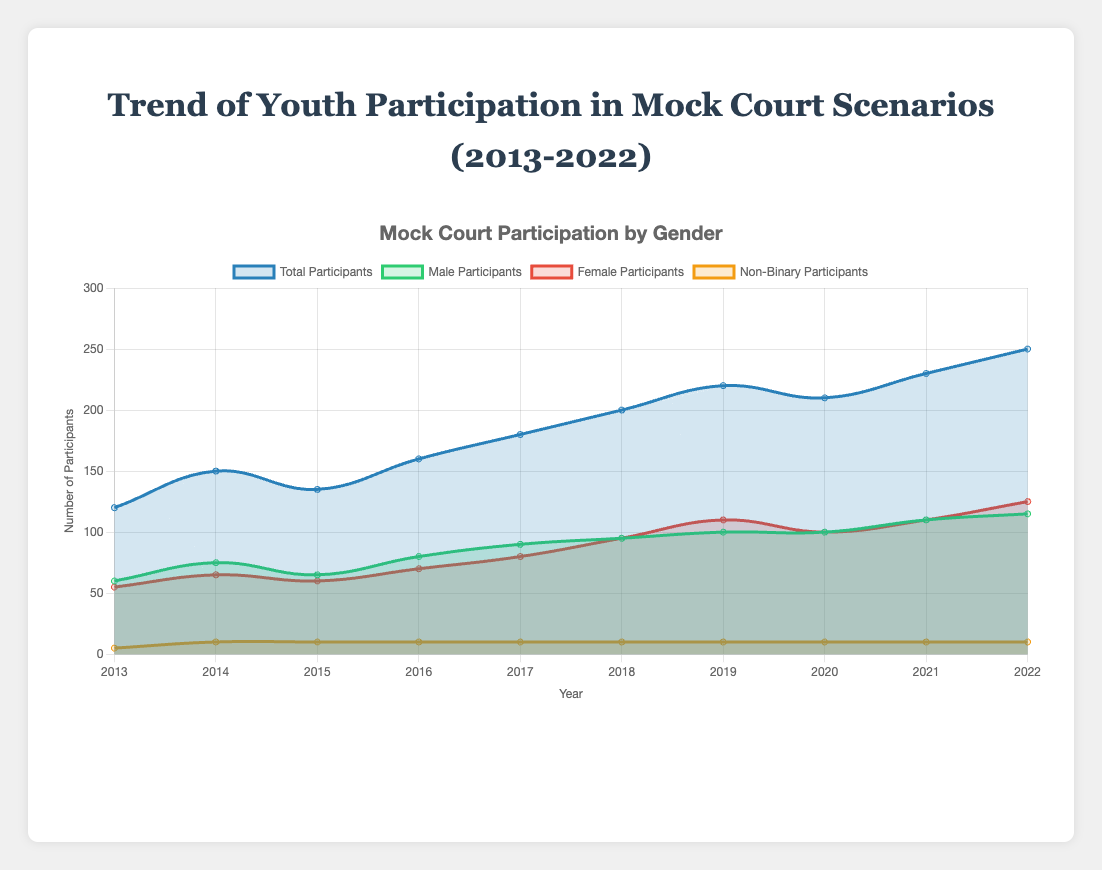What is the total number of participants in 2020? To find this, refer to the 'Total Participants' line in the chart and locate the data point for the year 2020. The value is 210.
Answer: 210 Which year had the highest number of female participants? Look at the 'Female Participants' line in the chart and identify the highest point. It occurs in 2022 with 125 participants.
Answer: 2022 How many more participants were there in 2022 compared to 2013? Subtract the number of participants in 2013 from those in 2022. 250 (2022) - 120 (2013) = 130.
Answer: 130 Which had more participants in 2019, male or female? Compare the 'Male Participants' and 'Female Participants' lines for the year 2019. The female participants had 110, while male participants had 100.
Answer: Female What is the average number of total participants over the decade? Sum the total participants from each year and divide by the number of years. (120+150+135+160+180+200+220+210+230+250) / 10 = 186.
Answer: 186 Between 2016 and 2018, which year saw the highest number of male participants? Refer to the 'Male Participants' line between the years 2016, 2017, and 2018. The highest point is in 2018 with 95 male participants.
Answer: 2018 What is the difference in non-binary participants between 2013 and 2014? Locate the 'Non-Binary Participants' line for these years. In 2013, there were 5 and in 2014, 10, so the difference is 10 - 5 = 5.
Answer: 5 Which year had the lowest judge count and how many judges were there? Refer to the judge count data for each year and identify the lowest value. In 2013 and 2015, the judge count was 3, the lowest in the dataset.
Answer: 2013 and 2015, 3 Has the trend of youth participation been generally increasing or decreasing? Observe the trend line for 'Total Participants'. The overall direction from 2013 to 2022 shows an upward trend.
Answer: Increasing 